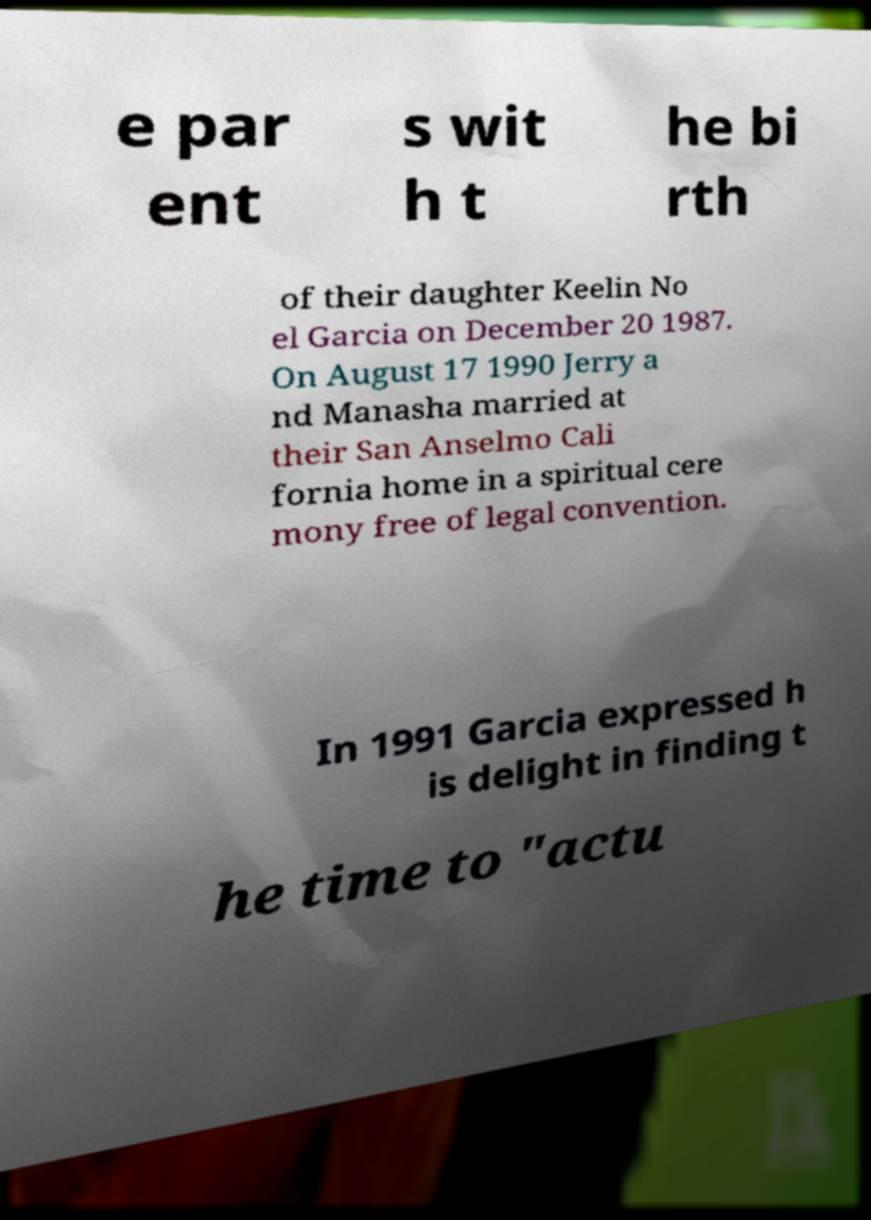Can you read and provide the text displayed in the image?This photo seems to have some interesting text. Can you extract and type it out for me? e par ent s wit h t he bi rth of their daughter Keelin No el Garcia on December 20 1987. On August 17 1990 Jerry a nd Manasha married at their San Anselmo Cali fornia home in a spiritual cere mony free of legal convention. In 1991 Garcia expressed h is delight in finding t he time to "actu 